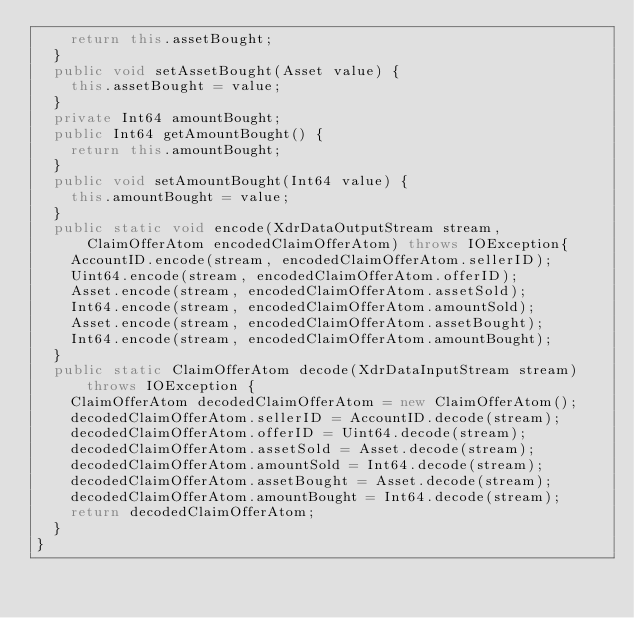<code> <loc_0><loc_0><loc_500><loc_500><_Java_>    return this.assetBought;
  }
  public void setAssetBought(Asset value) {
    this.assetBought = value;
  }
  private Int64 amountBought;
  public Int64 getAmountBought() {
    return this.amountBought;
  }
  public void setAmountBought(Int64 value) {
    this.amountBought = value;
  }
  public static void encode(XdrDataOutputStream stream, ClaimOfferAtom encodedClaimOfferAtom) throws IOException{
    AccountID.encode(stream, encodedClaimOfferAtom.sellerID);
    Uint64.encode(stream, encodedClaimOfferAtom.offerID);
    Asset.encode(stream, encodedClaimOfferAtom.assetSold);
    Int64.encode(stream, encodedClaimOfferAtom.amountSold);
    Asset.encode(stream, encodedClaimOfferAtom.assetBought);
    Int64.encode(stream, encodedClaimOfferAtom.amountBought);
  }
  public static ClaimOfferAtom decode(XdrDataInputStream stream) throws IOException {
    ClaimOfferAtom decodedClaimOfferAtom = new ClaimOfferAtom();
    decodedClaimOfferAtom.sellerID = AccountID.decode(stream);
    decodedClaimOfferAtom.offerID = Uint64.decode(stream);
    decodedClaimOfferAtom.assetSold = Asset.decode(stream);
    decodedClaimOfferAtom.amountSold = Int64.decode(stream);
    decodedClaimOfferAtom.assetBought = Asset.decode(stream);
    decodedClaimOfferAtom.amountBought = Int64.decode(stream);
    return decodedClaimOfferAtom;
  }
}
</code> 